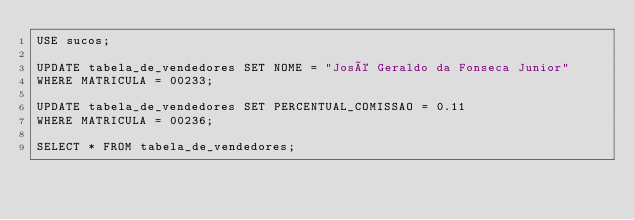Convert code to text. <code><loc_0><loc_0><loc_500><loc_500><_SQL_>USE sucos;

UPDATE tabela_de_vendedores SET NOME = "José Geraldo da Fonseca Junior"
WHERE MATRICULA = 00233;

UPDATE tabela_de_vendedores SET PERCENTUAL_COMISSAO = 0.11
WHERE MATRICULA = 00236;

SELECT * FROM tabela_de_vendedores;</code> 